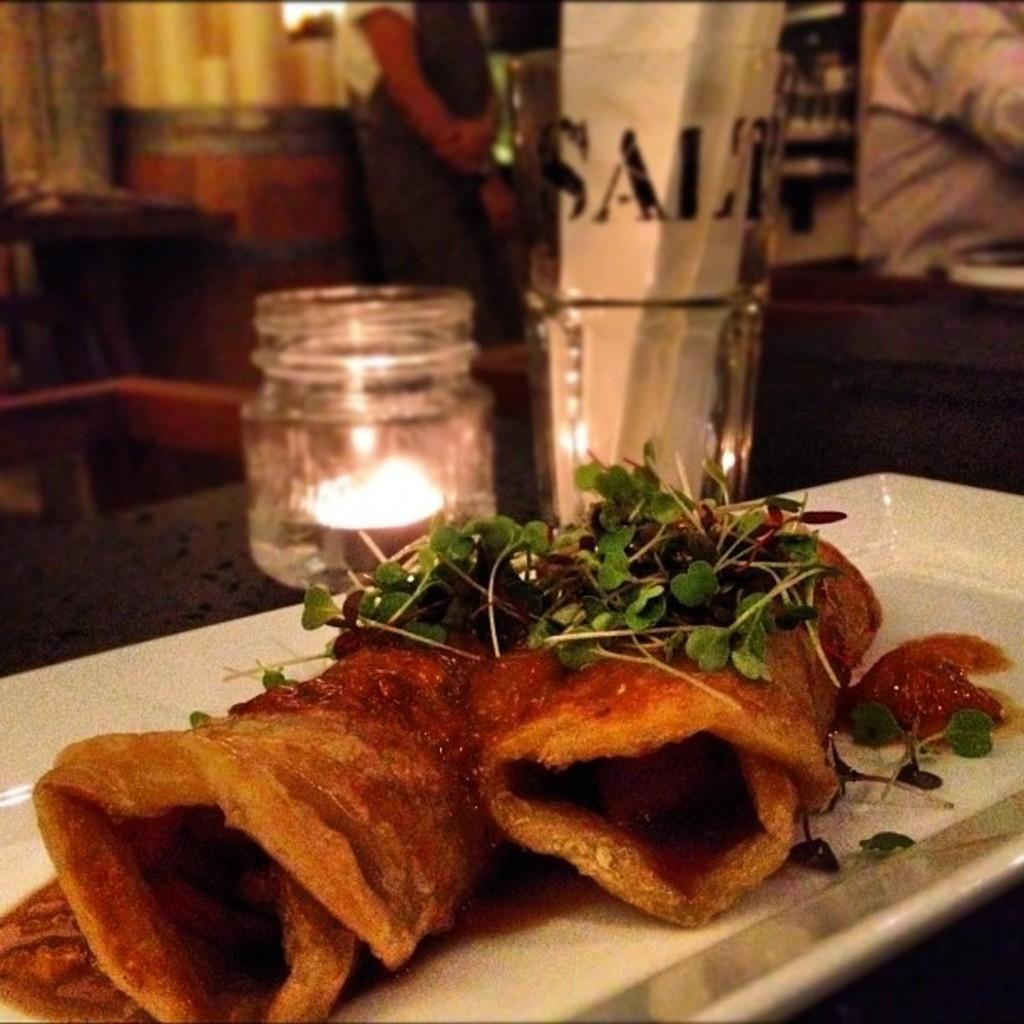Describe this image in one or two sentences. In the picture I can see some food item which is placed on the white color plate. The background of the image is slightly blurred, where I can see a candle is kept in the jar, I can see a glass and I can see a few people standing. 